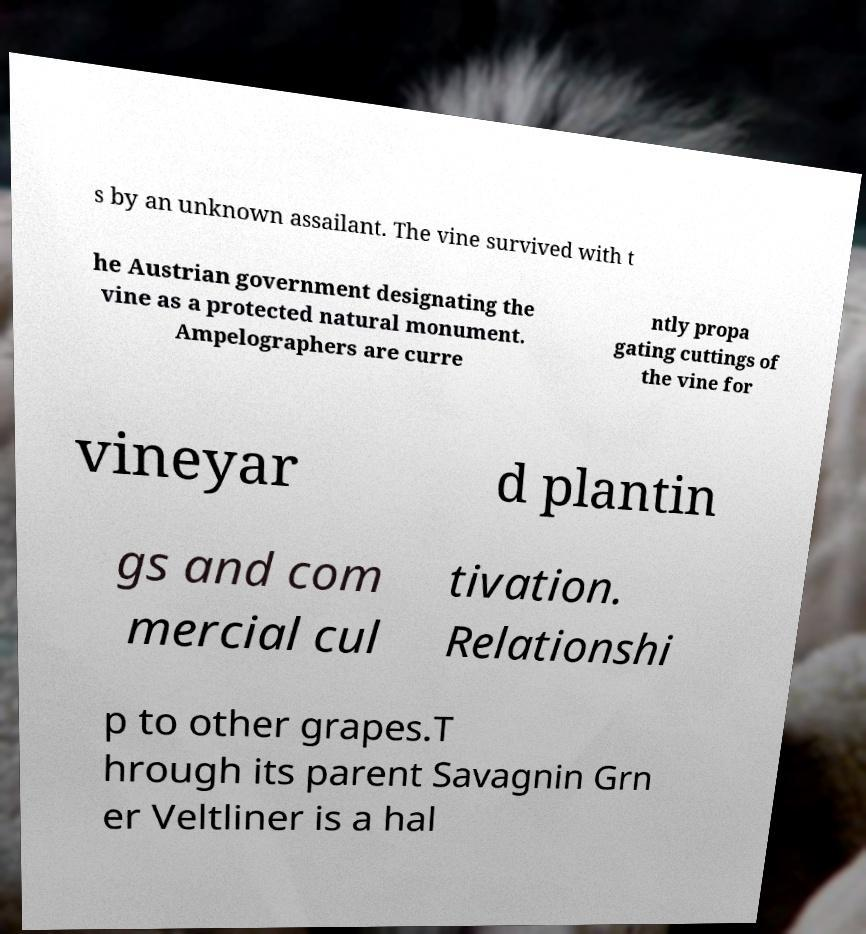Can you read and provide the text displayed in the image?This photo seems to have some interesting text. Can you extract and type it out for me? s by an unknown assailant. The vine survived with t he Austrian government designating the vine as a protected natural monument. Ampelographers are curre ntly propa gating cuttings of the vine for vineyar d plantin gs and com mercial cul tivation. Relationshi p to other grapes.T hrough its parent Savagnin Grn er Veltliner is a hal 